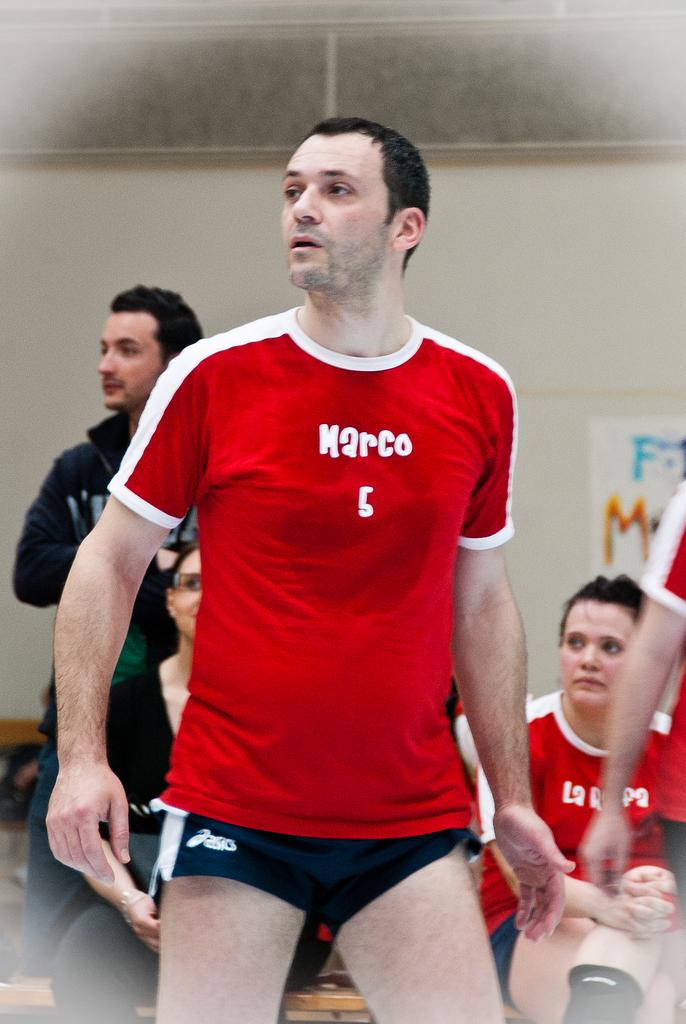What is on his shirt?
Ensure brevity in your answer.  Marco 5. What number does marco wear?
Offer a very short reply. 6. 